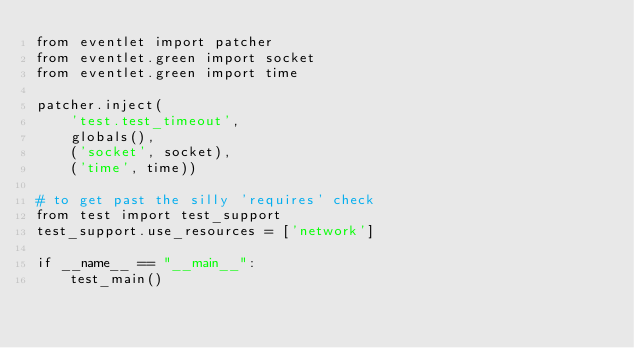Convert code to text. <code><loc_0><loc_0><loc_500><loc_500><_Python_>from eventlet import patcher
from eventlet.green import socket
from eventlet.green import time

patcher.inject(
    'test.test_timeout',
    globals(),
    ('socket', socket),
    ('time', time))

# to get past the silly 'requires' check
from test import test_support
test_support.use_resources = ['network']

if __name__ == "__main__":
    test_main()
</code> 